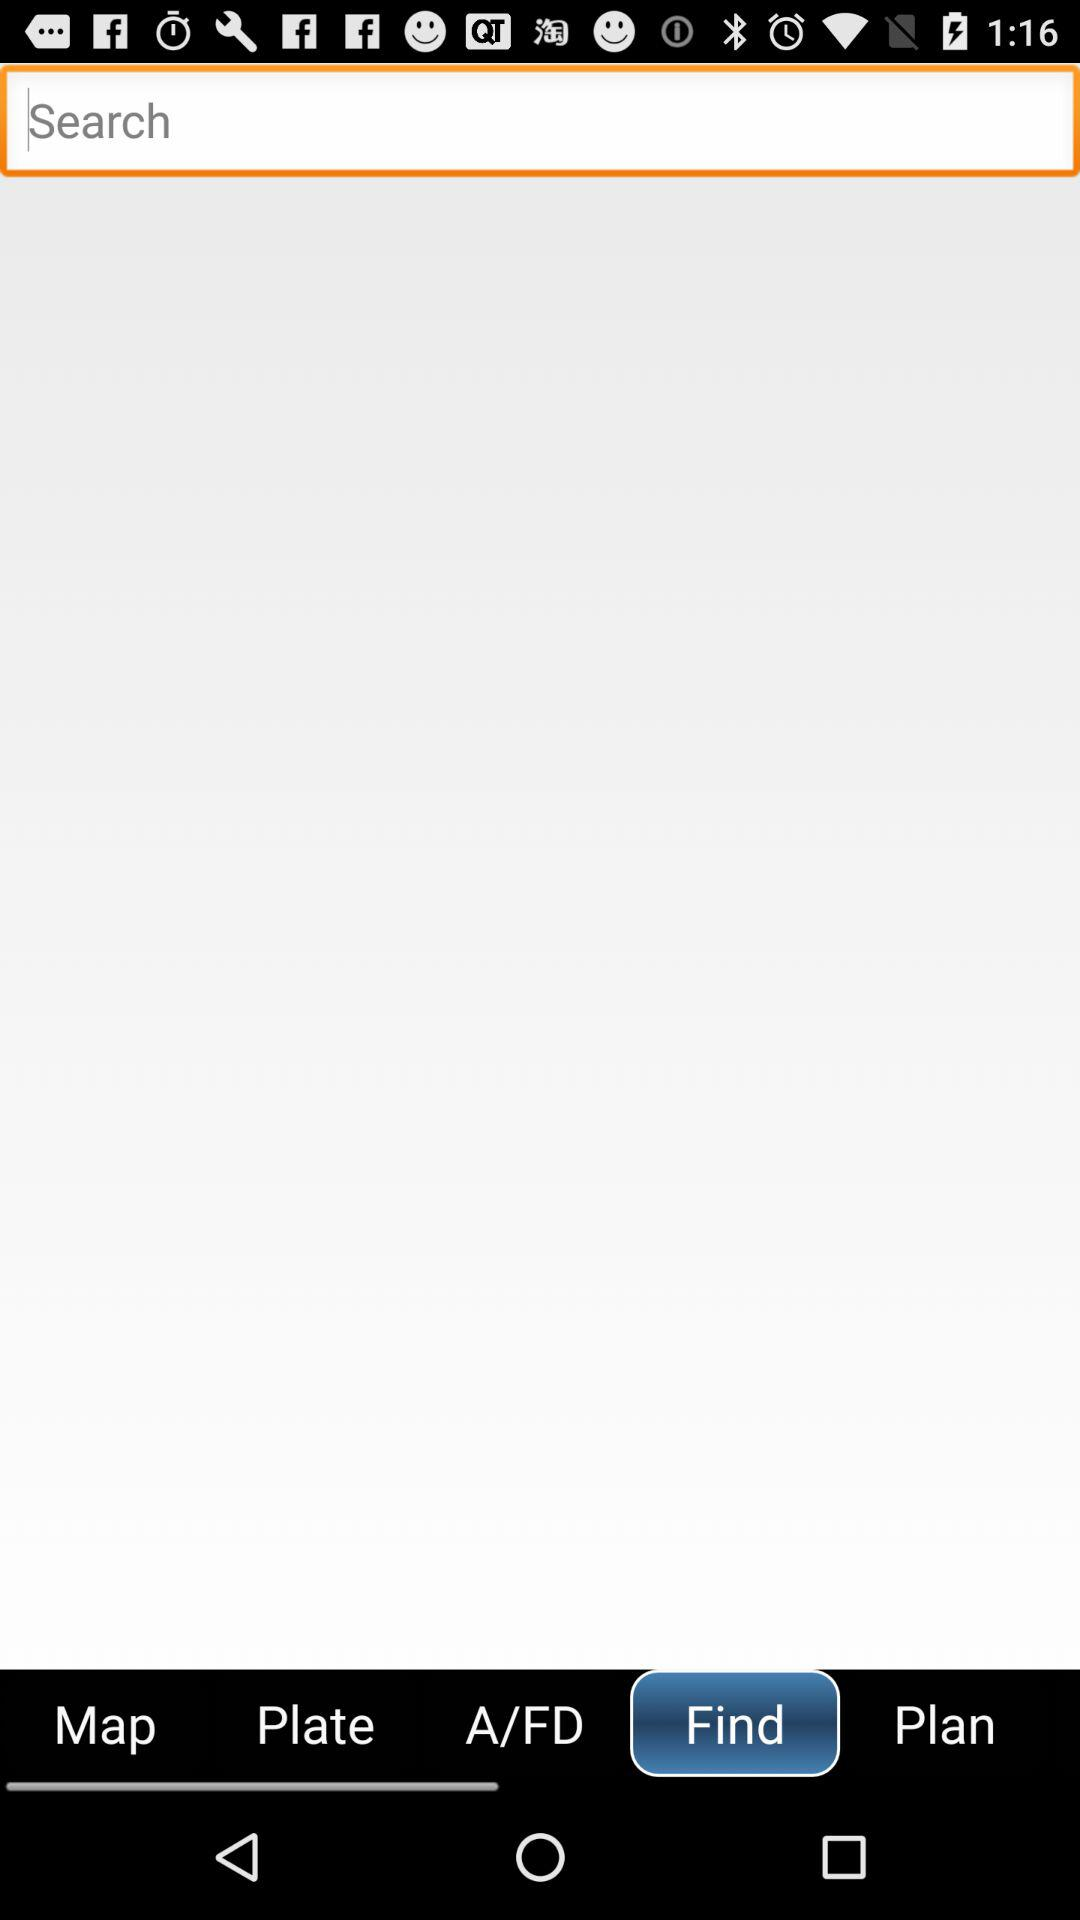Which tab is selected? The selected tab is "Find". 